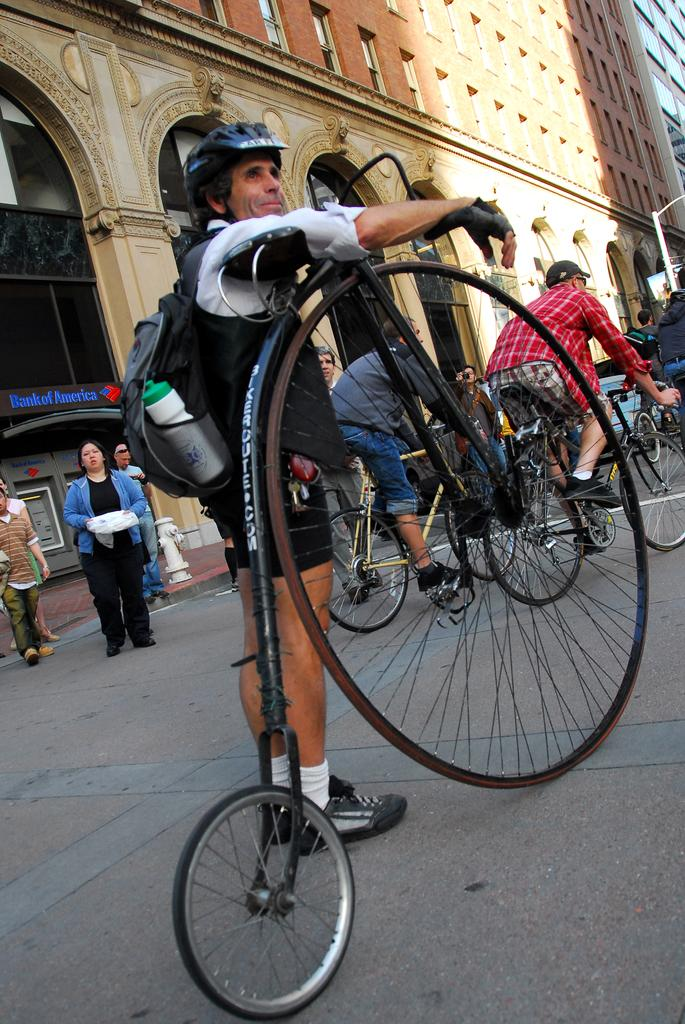What are the people in the image doing? There are people standing and riding bicycles in the image. What items can be seen with the people in the image? A backpack, a bottle, and a helmet are visible in the image. What can be seen in the background of the image? There are buildings in the background of the image. What type of oven can be seen in the image? There is no oven present in the image. How fast are the people running in the image? The people are not running in the image; they are standing or riding bicycles. 